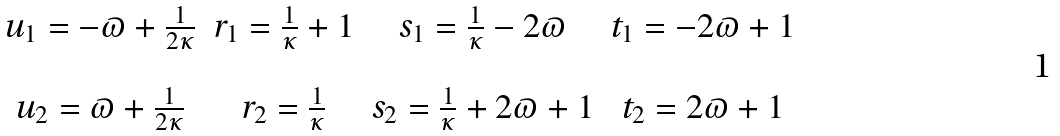Convert formula to latex. <formula><loc_0><loc_0><loc_500><loc_500>\begin{matrix} u _ { 1 } = - \varpi + \frac { 1 } { 2 \kappa } & r _ { 1 } = \frac { 1 } { \kappa } + 1 & s _ { 1 } = \frac { 1 } { \kappa } - 2 \varpi & t _ { 1 } = - 2 \varpi + 1 \\ \\ u _ { 2 } = \varpi + \frac { 1 } { 2 \kappa } & r _ { 2 } = \frac { 1 } { \kappa } & s _ { 2 } = \frac { 1 } { \kappa } + 2 \varpi + 1 & t _ { 2 } = 2 \varpi + 1 \end{matrix}</formula> 